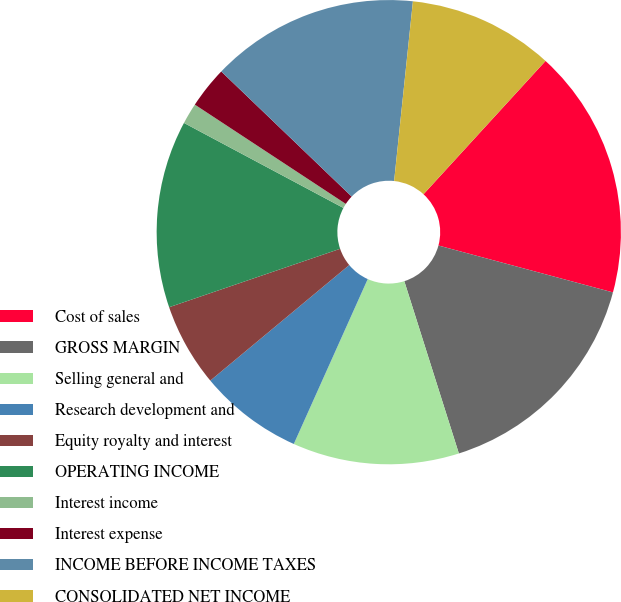<chart> <loc_0><loc_0><loc_500><loc_500><pie_chart><fcel>Cost of sales<fcel>GROSS MARGIN<fcel>Selling general and<fcel>Research development and<fcel>Equity royalty and interest<fcel>OPERATING INCOME<fcel>Interest income<fcel>Interest expense<fcel>INCOME BEFORE INCOME TAXES<fcel>CONSOLIDATED NET INCOME<nl><fcel>17.38%<fcel>15.94%<fcel>11.59%<fcel>7.25%<fcel>5.8%<fcel>13.04%<fcel>1.46%<fcel>2.91%<fcel>14.49%<fcel>10.14%<nl></chart> 